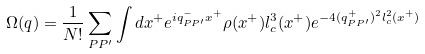<formula> <loc_0><loc_0><loc_500><loc_500>\Omega ( q ) = \frac { 1 } { N ! } \sum _ { P P ^ { \prime } } \int d x ^ { + } e ^ { i q _ { P P ^ { \prime } } ^ { - } x ^ { + } } \rho ( x ^ { + } ) l _ { c } ^ { 3 } ( x ^ { + } ) e ^ { - 4 ( q _ { P P ^ { \prime } } ^ { + } ) ^ { 2 } l _ { c } ^ { 2 } ( x ^ { + } ) }</formula> 